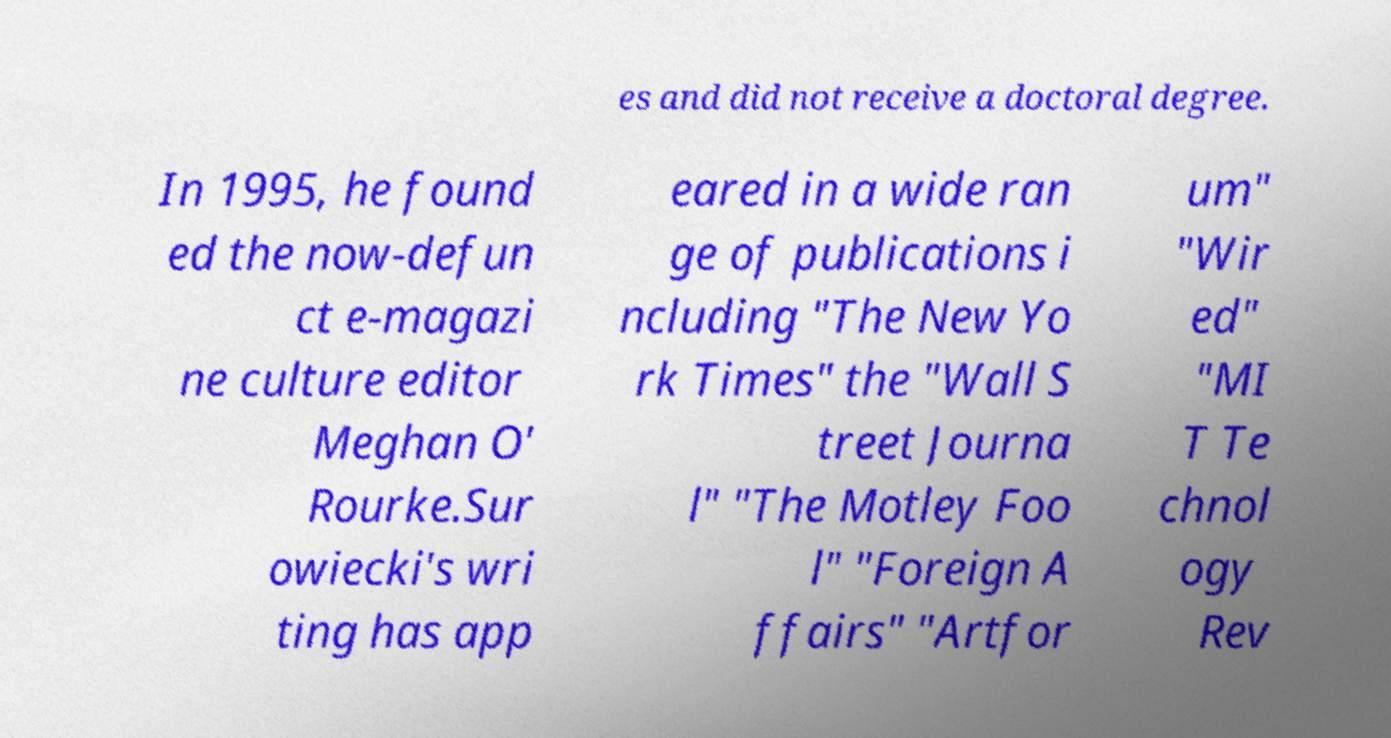For documentation purposes, I need the text within this image transcribed. Could you provide that? es and did not receive a doctoral degree. In 1995, he found ed the now-defun ct e-magazi ne culture editor Meghan O' Rourke.Sur owiecki's wri ting has app eared in a wide ran ge of publications i ncluding "The New Yo rk Times" the "Wall S treet Journa l" "The Motley Foo l" "Foreign A ffairs" "Artfor um" "Wir ed" "MI T Te chnol ogy Rev 